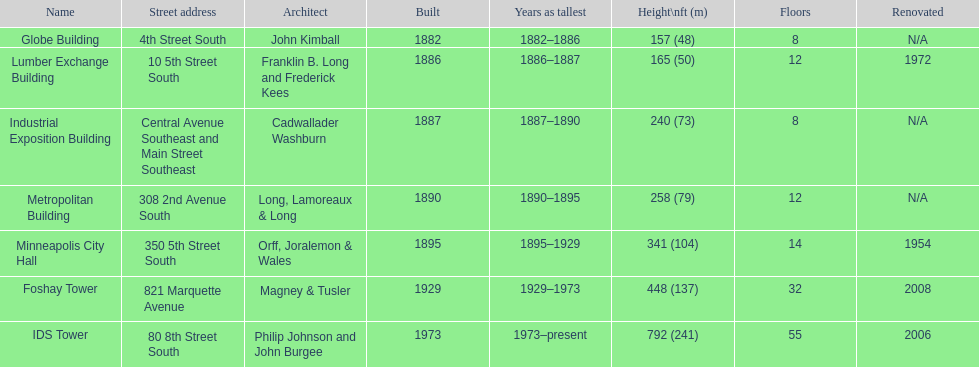Name the tallest building. IDS Tower. 